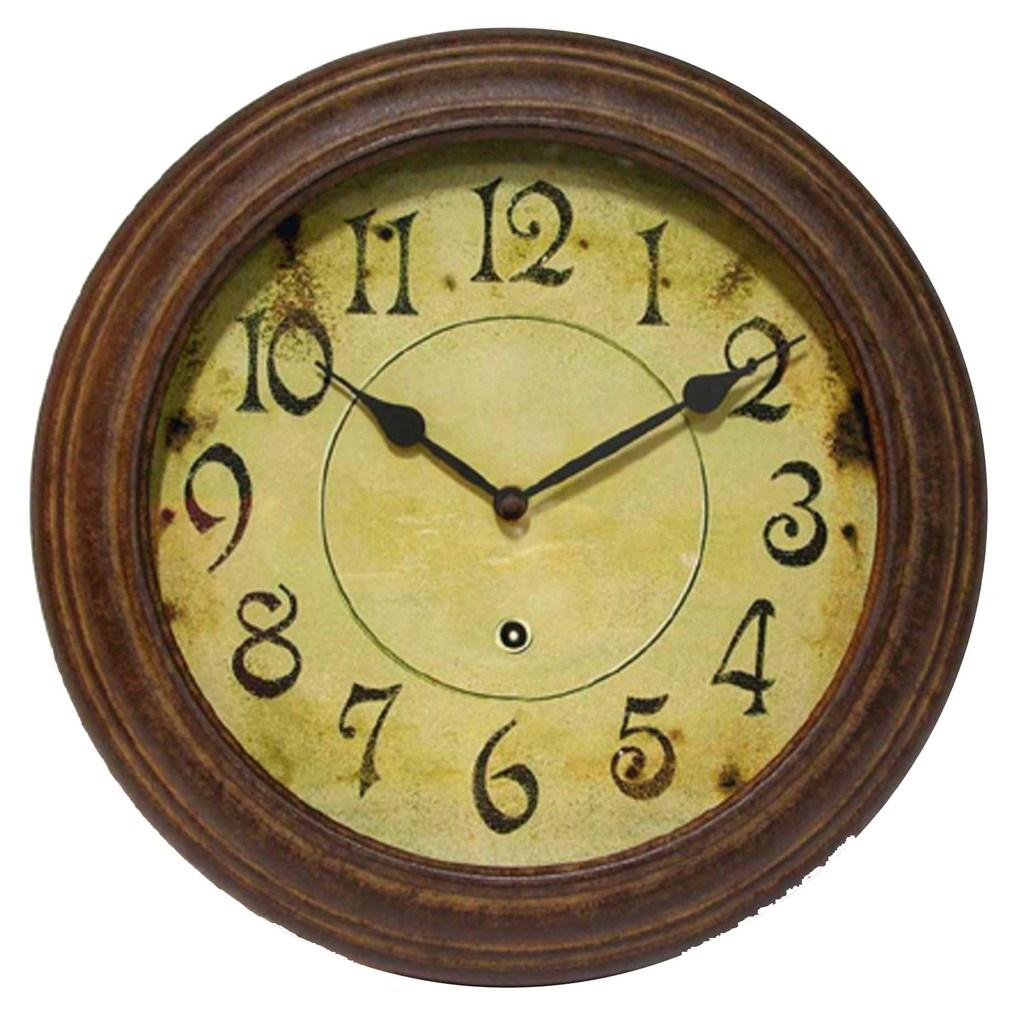What type of clock is in the image? There is a round wall clock in the image. What is the shape of the wall clock's frame? The wall clock has a round wooden frame. What type of can is visible in the image? There is no can present in the image; it only features a round wall clock with a wooden frame. 